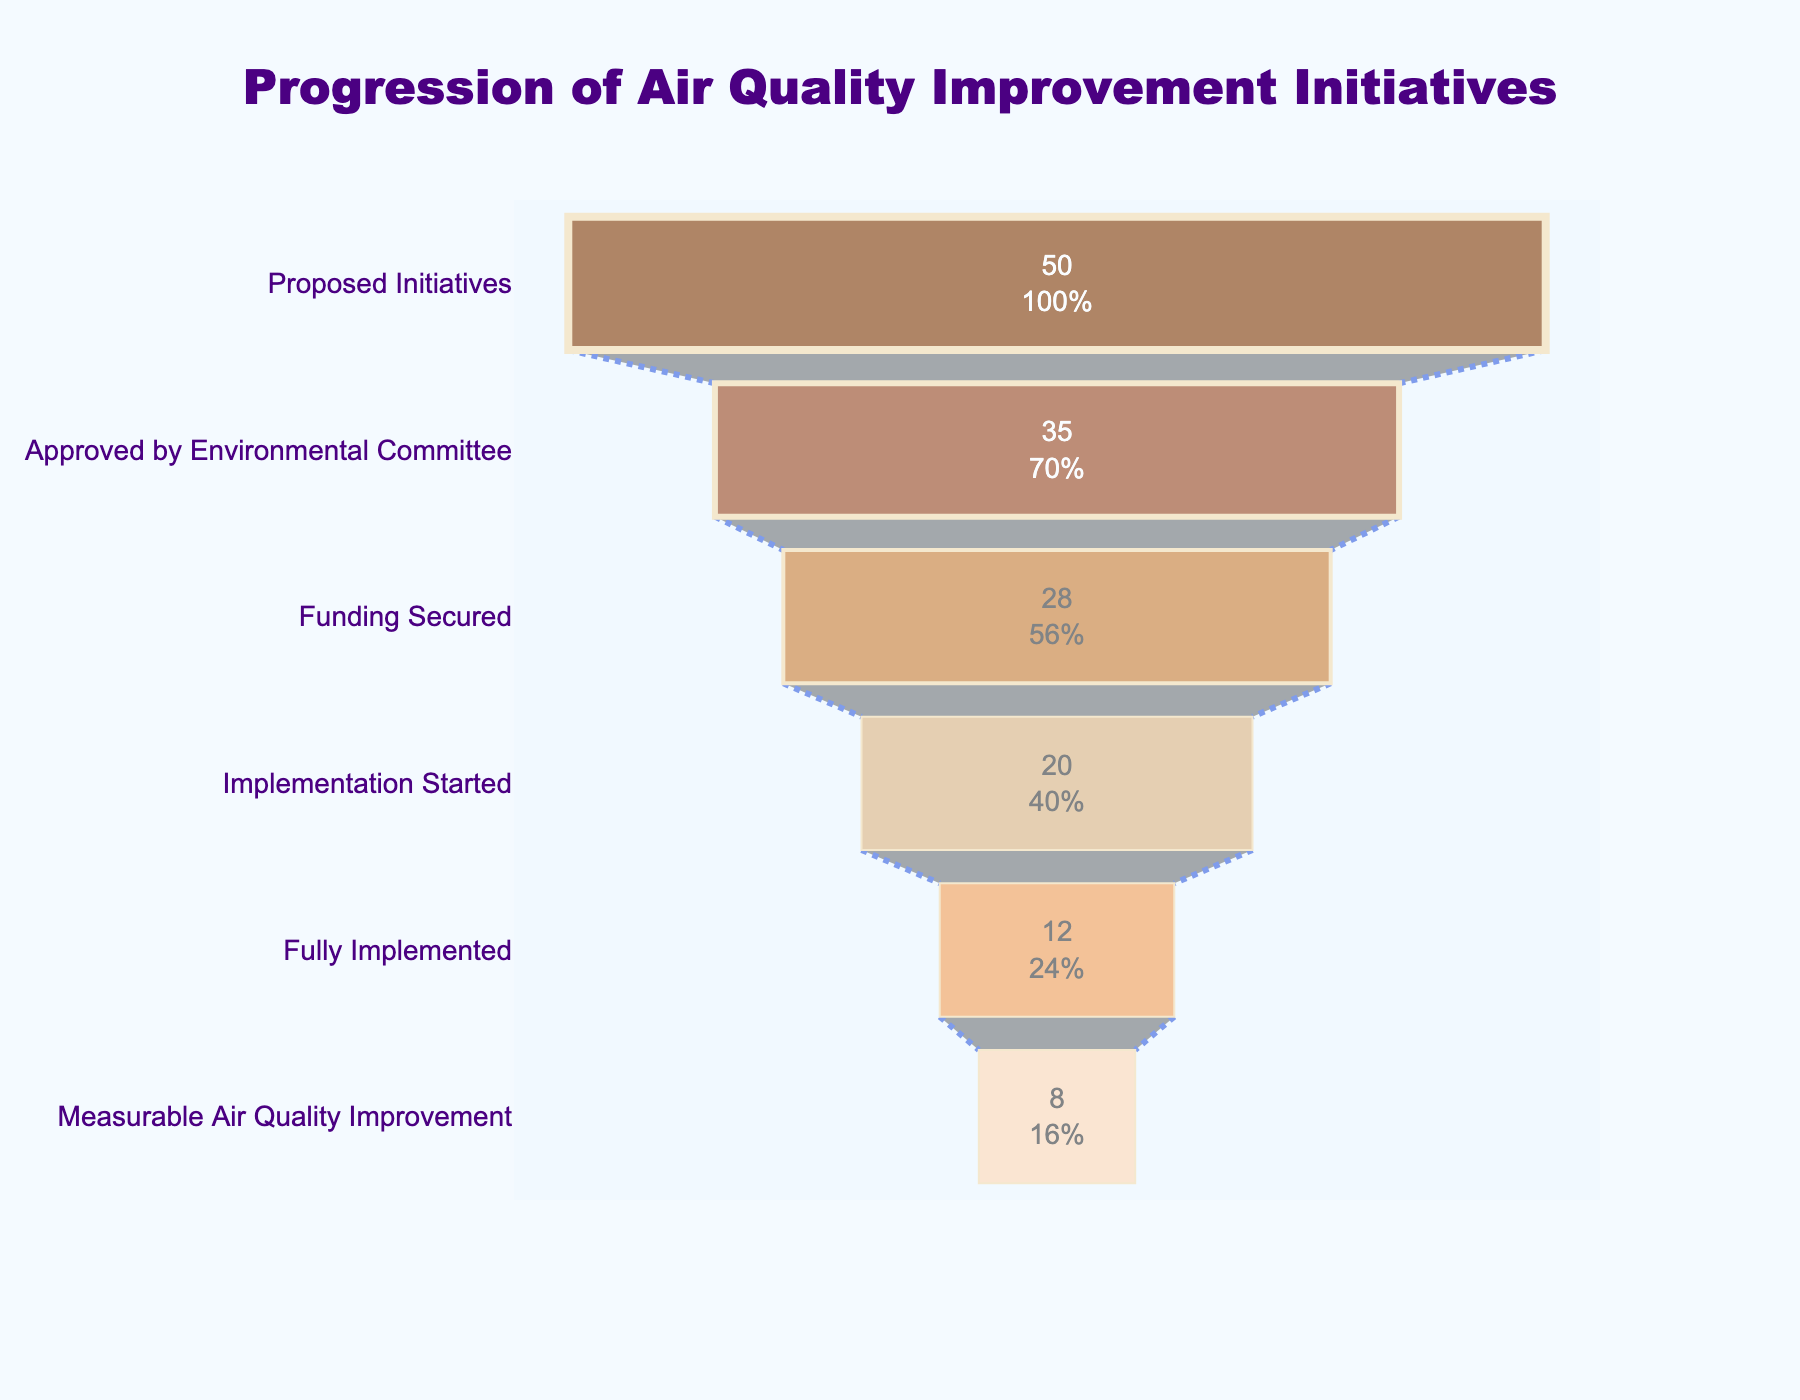What is the title of the funnel chart? The title of the chart can be found at the top and it describes the overall theme of the chart.
Answer: Progression of Air Quality Improvement Initiatives How many initiatives reached the stage of 'Funding Secured'? By looking at the bar labeled 'Funding Secured', you can see the number of initiatives in this stage.
Answer: 28 How many stages are presented in the funnel chart? Count the distinct labels along the y-axis representing different stages.
Answer: 6 What percentage of proposed initiatives were fully implemented? Divide the number of fully implemented initiatives by the number of proposed initiatives and multiply by 100: (12 / 50) * 100.
Answer: 24% Which stage shows the smallest number of initiatives? Identify the bar with the shortest length on the x-axis representing the smallest value.
Answer: Measurable Air Quality Improvement What is the difference between the number of initiatives at the approved stage and the fully implemented stage? Subtract the number of fully implemented initiatives from the number of approved initiatives: 35 - 12.
Answer: 23 What is the average number of initiatives from 'Approved by Environmental Committee' to 'Fully Implemented'? Sum the initiatives from the specified stages and divide by the number of stages: (35 + 28 + 20 + 12) / 4.
Answer: 23.75 In which stage do we see a reduction of 15 initiatives from the previous stage? Compare the number of initiatives between consecutive stages until you find a reduction of 15: Funding Secured (28) to Implementation Started (20).
Answer: Implementation Started Is the reduction from 'Implementation Started' to 'Fully Implemented' greater or less than the reduction from 'Fully Implemented' to 'Measurable Air Quality Improvement'? Subtract the number of initiatives in consecutive stages: (20 - 12) vs (12 - 8), and then compare them.
Answer: Greater How many initiatives did not secure funding? Subtract the number of initiatives that secured funding from those that were approved: 35 - 28.
Answer: 7 